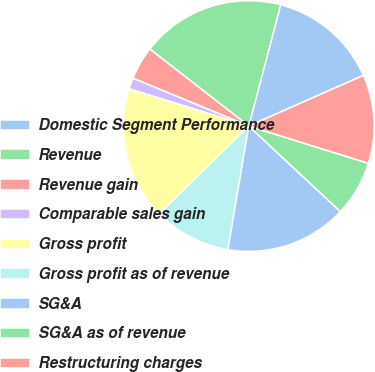Convert chart. <chart><loc_0><loc_0><loc_500><loc_500><pie_chart><fcel>Domestic Segment Performance<fcel>Revenue<fcel>Revenue gain<fcel>Comparable sales gain<fcel>Gross profit<fcel>Gross profit as of revenue<fcel>SG&A<fcel>SG&A as of revenue<fcel>Restructuring charges<nl><fcel>14.29%<fcel>18.57%<fcel>4.29%<fcel>1.43%<fcel>17.14%<fcel>10.0%<fcel>15.71%<fcel>7.14%<fcel>11.43%<nl></chart> 